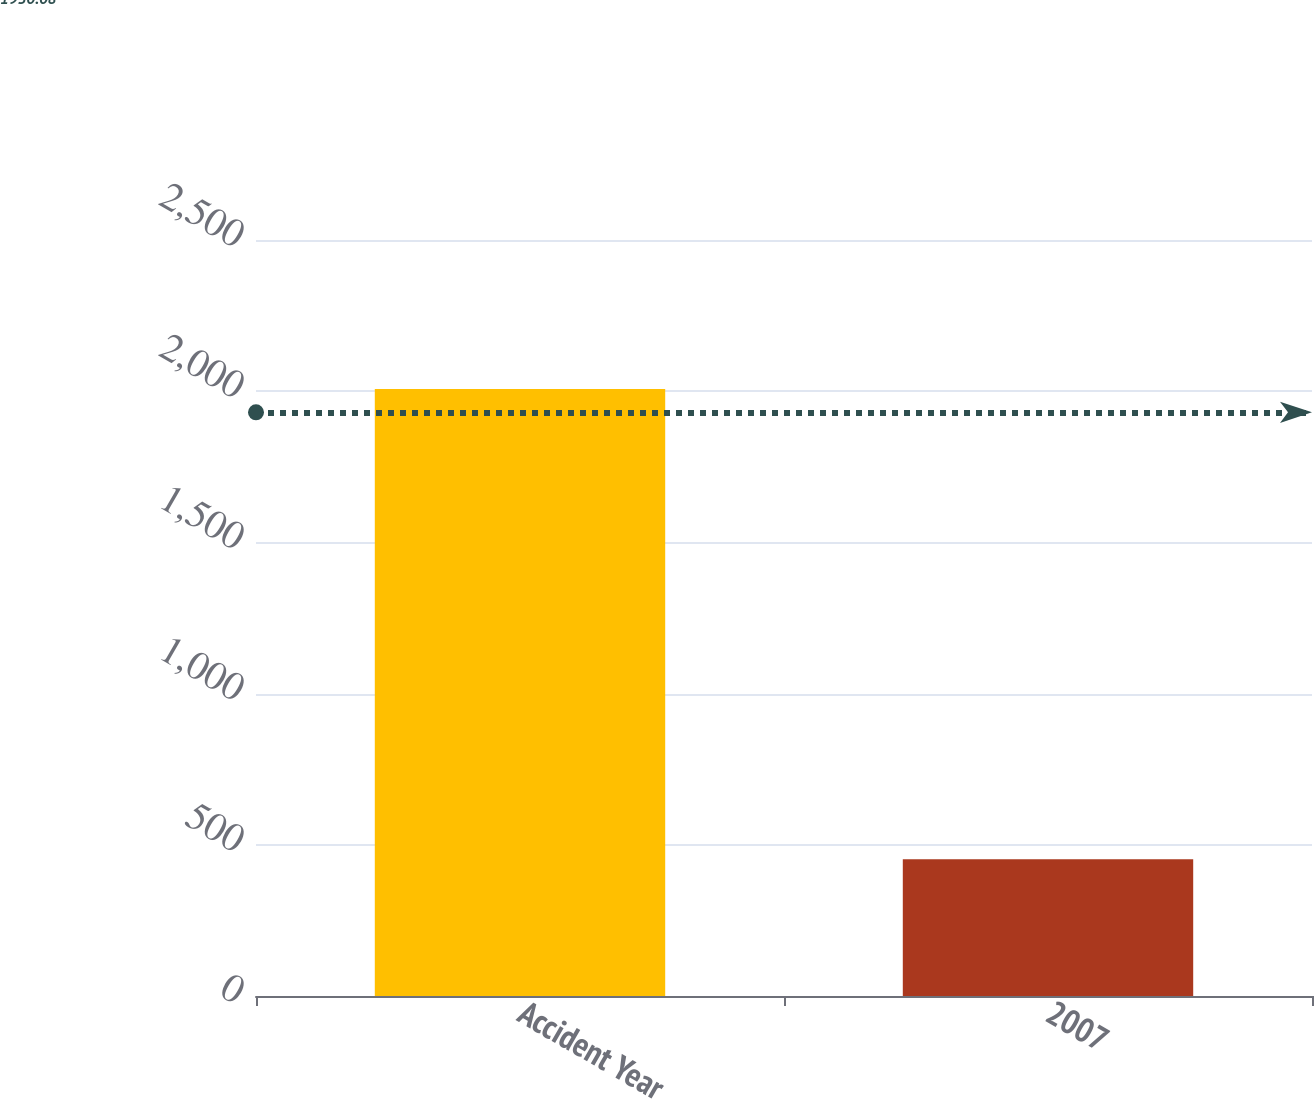<chart> <loc_0><loc_0><loc_500><loc_500><bar_chart><fcel>Accident Year<fcel>2007<nl><fcel>2007<fcel>452<nl></chart> 